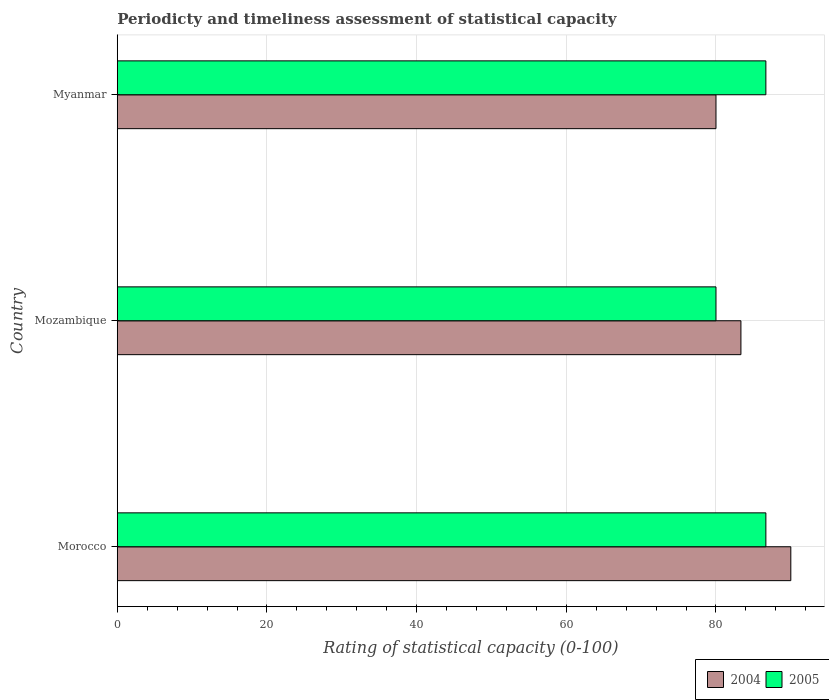Are the number of bars per tick equal to the number of legend labels?
Provide a succinct answer. Yes. How many bars are there on the 2nd tick from the top?
Make the answer very short. 2. What is the label of the 1st group of bars from the top?
Ensure brevity in your answer.  Myanmar. In how many cases, is the number of bars for a given country not equal to the number of legend labels?
Provide a short and direct response. 0. What is the rating of statistical capacity in 2004 in Myanmar?
Ensure brevity in your answer.  80. Across all countries, what is the maximum rating of statistical capacity in 2004?
Your answer should be compact. 90. Across all countries, what is the minimum rating of statistical capacity in 2004?
Your answer should be very brief. 80. In which country was the rating of statistical capacity in 2004 maximum?
Provide a succinct answer. Morocco. In which country was the rating of statistical capacity in 2004 minimum?
Offer a very short reply. Myanmar. What is the total rating of statistical capacity in 2004 in the graph?
Offer a very short reply. 253.33. What is the difference between the rating of statistical capacity in 2005 in Mozambique and that in Myanmar?
Your response must be concise. -6.67. What is the difference between the rating of statistical capacity in 2005 in Myanmar and the rating of statistical capacity in 2004 in Mozambique?
Make the answer very short. 3.33. What is the average rating of statistical capacity in 2005 per country?
Make the answer very short. 84.44. What is the difference between the rating of statistical capacity in 2005 and rating of statistical capacity in 2004 in Myanmar?
Your response must be concise. 6.67. In how many countries, is the rating of statistical capacity in 2005 greater than 36 ?
Offer a terse response. 3. What is the ratio of the rating of statistical capacity in 2004 in Mozambique to that in Myanmar?
Offer a terse response. 1.04. Is the rating of statistical capacity in 2004 in Morocco less than that in Myanmar?
Provide a short and direct response. No. Is the difference between the rating of statistical capacity in 2005 in Morocco and Myanmar greater than the difference between the rating of statistical capacity in 2004 in Morocco and Myanmar?
Your answer should be compact. No. What is the difference between the highest and the second highest rating of statistical capacity in 2005?
Your answer should be compact. 0. What is the difference between the highest and the lowest rating of statistical capacity in 2004?
Provide a succinct answer. 10. In how many countries, is the rating of statistical capacity in 2004 greater than the average rating of statistical capacity in 2004 taken over all countries?
Make the answer very short. 1. Is the sum of the rating of statistical capacity in 2004 in Mozambique and Myanmar greater than the maximum rating of statistical capacity in 2005 across all countries?
Keep it short and to the point. Yes. What does the 2nd bar from the top in Morocco represents?
Give a very brief answer. 2004. What does the 2nd bar from the bottom in Myanmar represents?
Your answer should be compact. 2005. Are all the bars in the graph horizontal?
Make the answer very short. Yes. How many countries are there in the graph?
Ensure brevity in your answer.  3. Are the values on the major ticks of X-axis written in scientific E-notation?
Give a very brief answer. No. Does the graph contain any zero values?
Offer a terse response. No. Does the graph contain grids?
Offer a very short reply. Yes. How many legend labels are there?
Give a very brief answer. 2. How are the legend labels stacked?
Your answer should be very brief. Horizontal. What is the title of the graph?
Make the answer very short. Periodicty and timeliness assessment of statistical capacity. Does "2009" appear as one of the legend labels in the graph?
Your response must be concise. No. What is the label or title of the X-axis?
Make the answer very short. Rating of statistical capacity (0-100). What is the label or title of the Y-axis?
Offer a very short reply. Country. What is the Rating of statistical capacity (0-100) of 2005 in Morocco?
Provide a short and direct response. 86.67. What is the Rating of statistical capacity (0-100) of 2004 in Mozambique?
Your response must be concise. 83.33. What is the Rating of statistical capacity (0-100) of 2005 in Myanmar?
Provide a short and direct response. 86.67. Across all countries, what is the maximum Rating of statistical capacity (0-100) of 2004?
Make the answer very short. 90. Across all countries, what is the maximum Rating of statistical capacity (0-100) in 2005?
Your response must be concise. 86.67. Across all countries, what is the minimum Rating of statistical capacity (0-100) in 2005?
Give a very brief answer. 80. What is the total Rating of statistical capacity (0-100) in 2004 in the graph?
Keep it short and to the point. 253.33. What is the total Rating of statistical capacity (0-100) in 2005 in the graph?
Make the answer very short. 253.33. What is the difference between the Rating of statistical capacity (0-100) of 2005 in Morocco and that in Mozambique?
Provide a short and direct response. 6.67. What is the difference between the Rating of statistical capacity (0-100) in 2004 in Morocco and that in Myanmar?
Provide a succinct answer. 10. What is the difference between the Rating of statistical capacity (0-100) in 2005 in Mozambique and that in Myanmar?
Your answer should be very brief. -6.67. What is the difference between the Rating of statistical capacity (0-100) in 2004 in Mozambique and the Rating of statistical capacity (0-100) in 2005 in Myanmar?
Your response must be concise. -3.33. What is the average Rating of statistical capacity (0-100) in 2004 per country?
Offer a very short reply. 84.44. What is the average Rating of statistical capacity (0-100) of 2005 per country?
Keep it short and to the point. 84.44. What is the difference between the Rating of statistical capacity (0-100) in 2004 and Rating of statistical capacity (0-100) in 2005 in Mozambique?
Your response must be concise. 3.33. What is the difference between the Rating of statistical capacity (0-100) in 2004 and Rating of statistical capacity (0-100) in 2005 in Myanmar?
Give a very brief answer. -6.67. What is the ratio of the Rating of statistical capacity (0-100) of 2004 in Morocco to that in Mozambique?
Your answer should be very brief. 1.08. What is the ratio of the Rating of statistical capacity (0-100) in 2004 in Mozambique to that in Myanmar?
Offer a very short reply. 1.04. What is the ratio of the Rating of statistical capacity (0-100) in 2005 in Mozambique to that in Myanmar?
Provide a succinct answer. 0.92. What is the difference between the highest and the second highest Rating of statistical capacity (0-100) of 2005?
Ensure brevity in your answer.  0. What is the difference between the highest and the lowest Rating of statistical capacity (0-100) in 2005?
Your response must be concise. 6.67. 